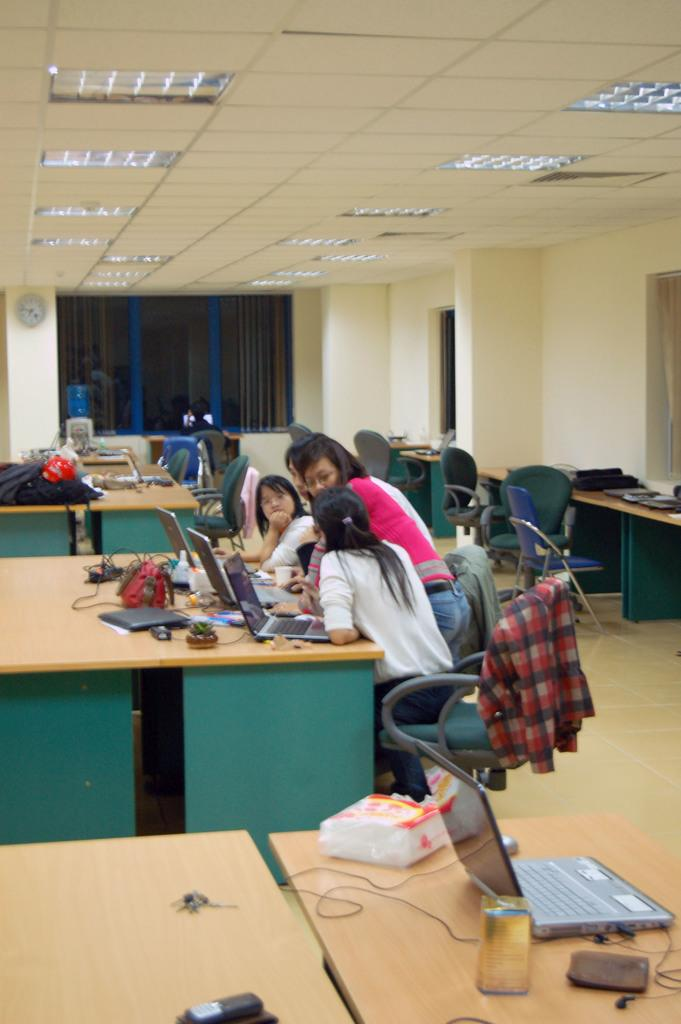What type of furniture is present in the image? There are tables and chairs in the image. What are the people sitting on? The people are sitting on chairs in the image. What is covering the table? There is a cover on the table. What electronic devices can be seen on the table? There is a mobile phone and a laptop on the table. What type of road can be seen in the image? There is no road present in the image. What kind of beast is interacting with the laptop on the table? There is no beast present in the image, and the laptop is not being interacted with by any creature. 